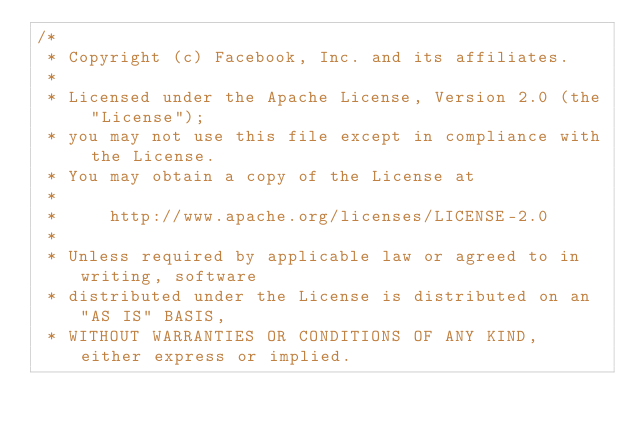<code> <loc_0><loc_0><loc_500><loc_500><_Java_>/*
 * Copyright (c) Facebook, Inc. and its affiliates.
 *
 * Licensed under the Apache License, Version 2.0 (the "License");
 * you may not use this file except in compliance with the License.
 * You may obtain a copy of the License at
 *
 *     http://www.apache.org/licenses/LICENSE-2.0
 *
 * Unless required by applicable law or agreed to in writing, software
 * distributed under the License is distributed on an "AS IS" BASIS,
 * WITHOUT WARRANTIES OR CONDITIONS OF ANY KIND, either express or implied.</code> 